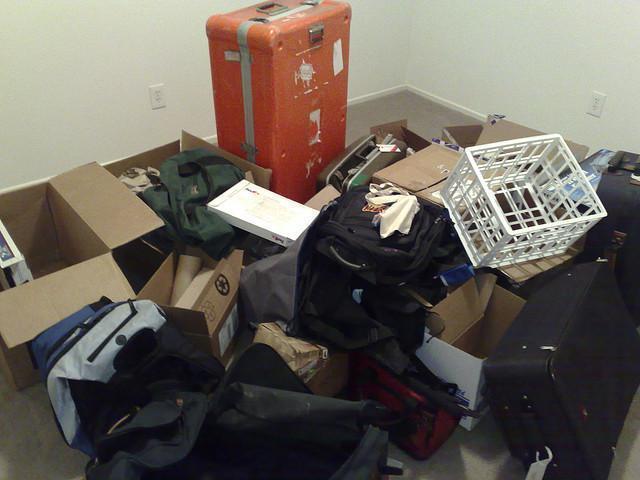What is someone who collects huge amounts of rubbish called?
Make your selection from the four choices given to correctly answer the question.
Options: Hoarder, butler, collector, miscreant. Hoarder. 